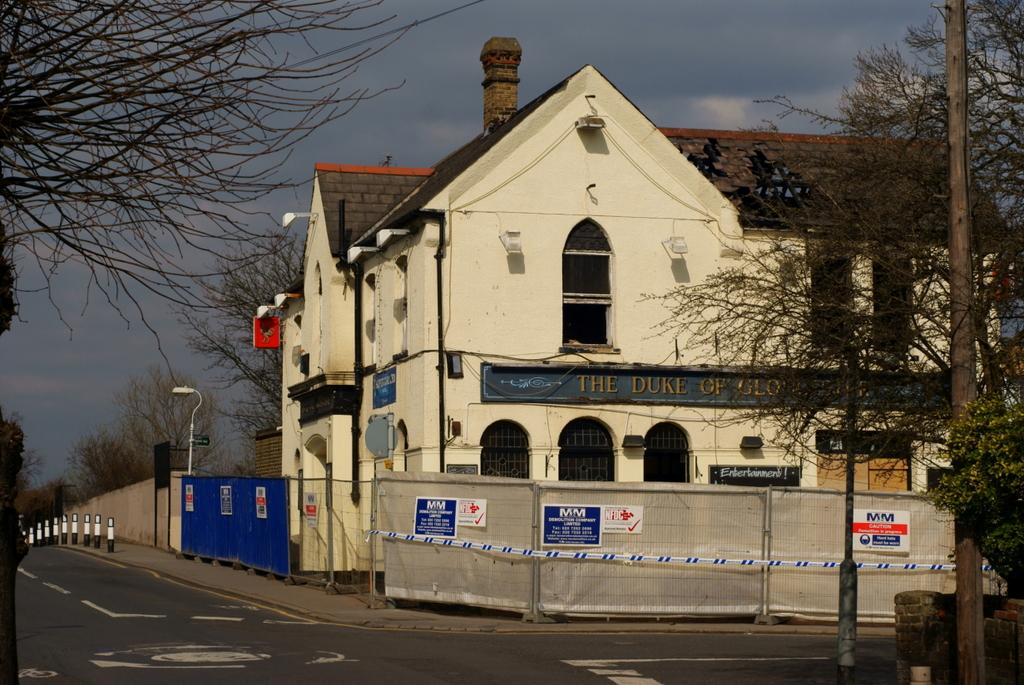What type of structure can be seen in the image? There is a building in the image. What other natural elements are present in the image? There are trees in the image. What man-made objects can be seen in the image? There are poles, lights, boards, and posters on a wall in the image. What is visible in the background of the image? The sky is visible in the background of the image, and clouds are present in the sky. Can you tell me how many bears are sitting on the boards in the image? There are no bears present in the image; it features a building, trees, poles, lights, boards, posters, and a sky with clouds. What type of quartz can be seen in the image? There is no quartz present in the image. Is there a cow grazing in the background of the image? There is no cow present in the image; it features a building, trees, poles, lights, boards, posters, and a sky with clouds. 